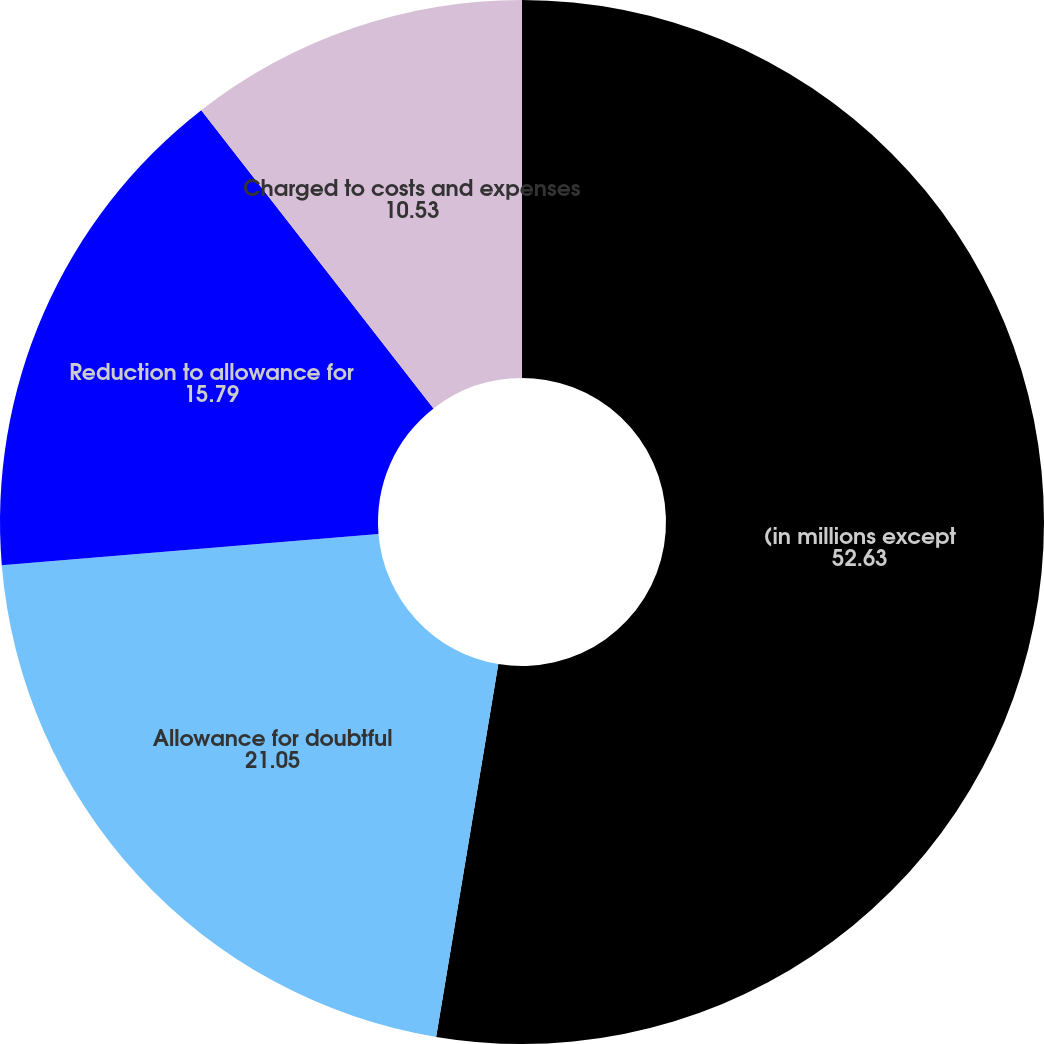Convert chart. <chart><loc_0><loc_0><loc_500><loc_500><pie_chart><fcel>(in millions except<fcel>Allowance for doubtful<fcel>Reduction to allowance for<fcel>Charged to costs and expenses<fcel>Allowance as a percentage of<nl><fcel>52.63%<fcel>21.05%<fcel>15.79%<fcel>10.53%<fcel>0.0%<nl></chart> 